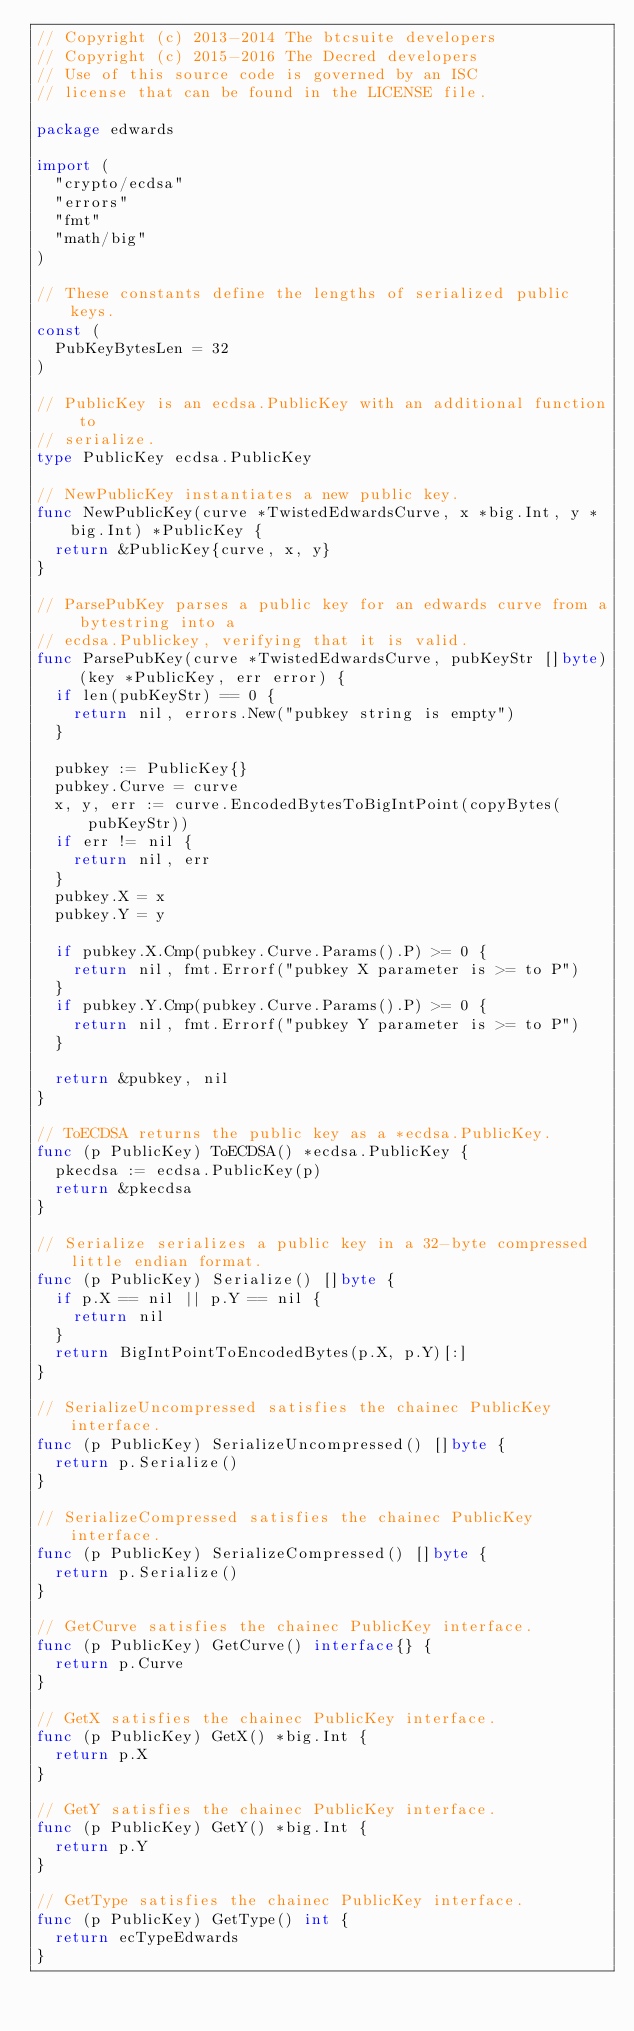<code> <loc_0><loc_0><loc_500><loc_500><_Go_>// Copyright (c) 2013-2014 The btcsuite developers
// Copyright (c) 2015-2016 The Decred developers
// Use of this source code is governed by an ISC
// license that can be found in the LICENSE file.

package edwards

import (
	"crypto/ecdsa"
	"errors"
	"fmt"
	"math/big"
)

// These constants define the lengths of serialized public keys.
const (
	PubKeyBytesLen = 32
)

// PublicKey is an ecdsa.PublicKey with an additional function to
// serialize.
type PublicKey ecdsa.PublicKey

// NewPublicKey instantiates a new public key.
func NewPublicKey(curve *TwistedEdwardsCurve, x *big.Int, y *big.Int) *PublicKey {
	return &PublicKey{curve, x, y}
}

// ParsePubKey parses a public key for an edwards curve from a bytestring into a
// ecdsa.Publickey, verifying that it is valid.
func ParsePubKey(curve *TwistedEdwardsCurve, pubKeyStr []byte) (key *PublicKey, err error) {
	if len(pubKeyStr) == 0 {
		return nil, errors.New("pubkey string is empty")
	}

	pubkey := PublicKey{}
	pubkey.Curve = curve
	x, y, err := curve.EncodedBytesToBigIntPoint(copyBytes(pubKeyStr))
	if err != nil {
		return nil, err
	}
	pubkey.X = x
	pubkey.Y = y

	if pubkey.X.Cmp(pubkey.Curve.Params().P) >= 0 {
		return nil, fmt.Errorf("pubkey X parameter is >= to P")
	}
	if pubkey.Y.Cmp(pubkey.Curve.Params().P) >= 0 {
		return nil, fmt.Errorf("pubkey Y parameter is >= to P")
	}

	return &pubkey, nil
}

// ToECDSA returns the public key as a *ecdsa.PublicKey.
func (p PublicKey) ToECDSA() *ecdsa.PublicKey {
	pkecdsa := ecdsa.PublicKey(p)
	return &pkecdsa
}

// Serialize serializes a public key in a 32-byte compressed little endian format.
func (p PublicKey) Serialize() []byte {
	if p.X == nil || p.Y == nil {
		return nil
	}
	return BigIntPointToEncodedBytes(p.X, p.Y)[:]
}

// SerializeUncompressed satisfies the chainec PublicKey interface.
func (p PublicKey) SerializeUncompressed() []byte {
	return p.Serialize()
}

// SerializeCompressed satisfies the chainec PublicKey interface.
func (p PublicKey) SerializeCompressed() []byte {
	return p.Serialize()
}

// GetCurve satisfies the chainec PublicKey interface.
func (p PublicKey) GetCurve() interface{} {
	return p.Curve
}

// GetX satisfies the chainec PublicKey interface.
func (p PublicKey) GetX() *big.Int {
	return p.X
}

// GetY satisfies the chainec PublicKey interface.
func (p PublicKey) GetY() *big.Int {
	return p.Y
}

// GetType satisfies the chainec PublicKey interface.
func (p PublicKey) GetType() int {
	return ecTypeEdwards
}
</code> 